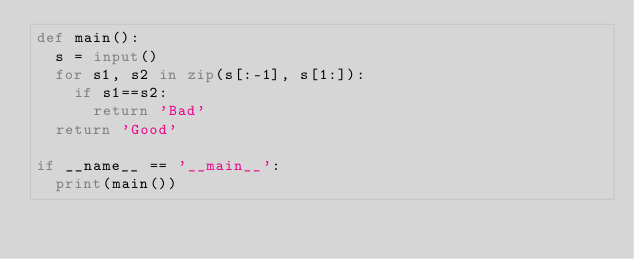<code> <loc_0><loc_0><loc_500><loc_500><_Python_>def main():
  s = input()
  for s1, s2 in zip(s[:-1], s[1:]):
    if s1==s2:
      return 'Bad'
  return 'Good'

if __name__ == '__main__':
  print(main())</code> 